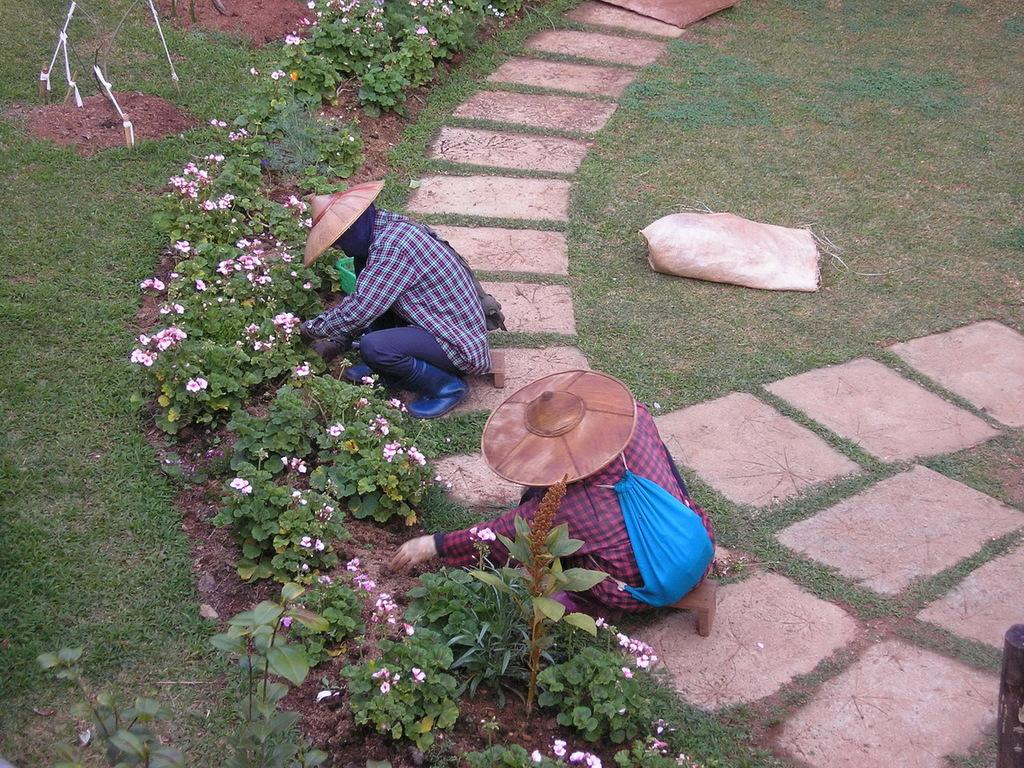How many people are present in the image? There are two persons sitting in the image. What are the persons holding in the image? The persons are holding plants. What else can be seen in the background of the image? There are plants visible behind the persons. What type of natural environment is visible in the image? There is grass visible in the image. What type of brain can be seen in the image? There is no brain visible in the image; it features two persons holding plants. Are the persons in the image on vacation? The image does not provide any information about the persons' location or activity, so it cannot be determined if they are on vacation. 